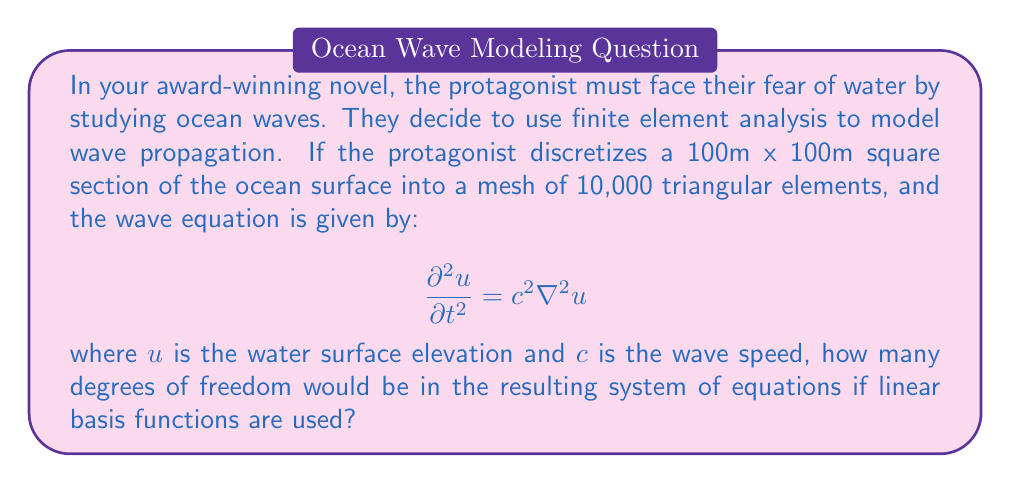Help me with this question. To solve this problem, we need to follow these steps:

1) In finite element analysis for 2D problems, the degrees of freedom (DOF) are typically associated with the nodes of the mesh.

2) For a triangular mesh, we can use the relationship between the number of elements and nodes. For a large mesh, this relationship is approximately:

   $N \approx \frac{E}{2} + 1$

   where $N$ is the number of nodes and $E$ is the number of elements.

3) In this case, $E = 10,000$, so:

   $N \approx \frac{10,000}{2} + 1 = 5,001$

4) When using linear basis functions in 2D, each node typically has one degree of freedom (the value of $u$ at that node).

5) Therefore, the total number of degrees of freedom is equal to the number of nodes:

   $DOF = N \approx 5,001$

This approximation is valid for large meshes where boundary effects are negligible.
Answer: 5,001 